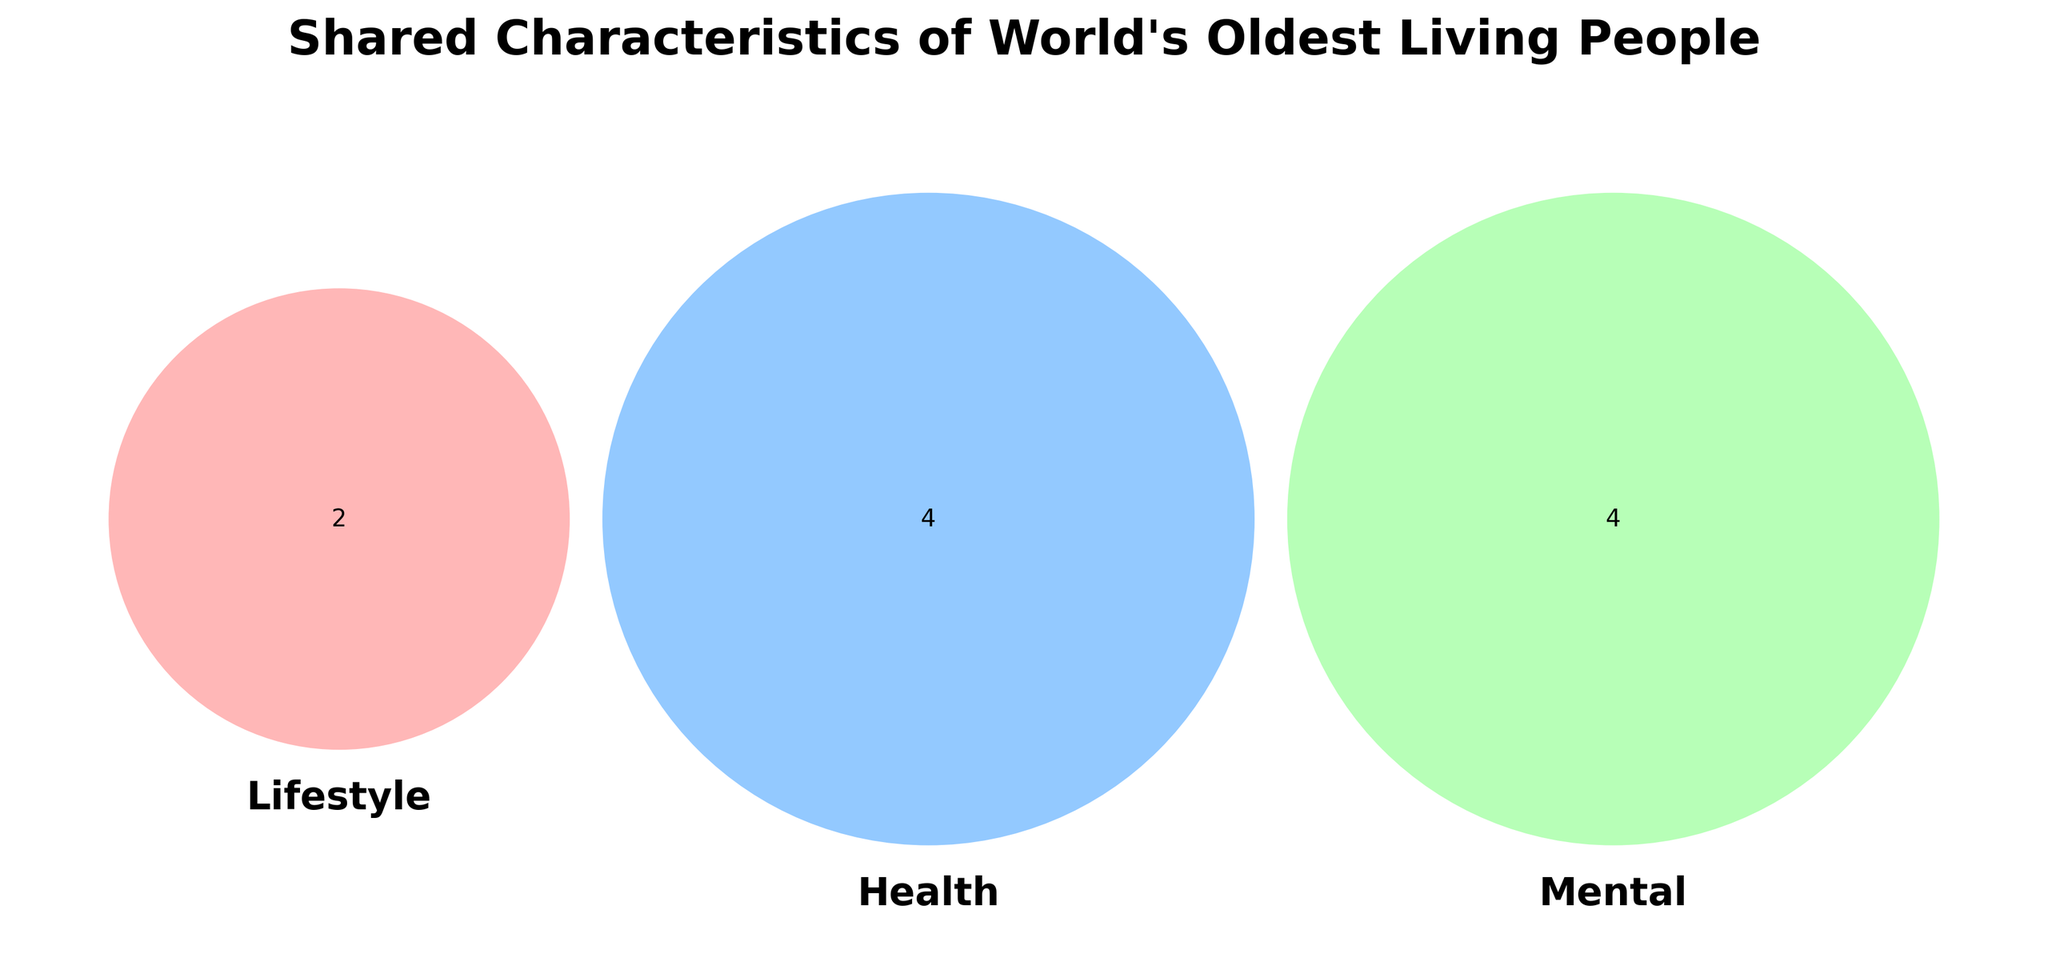What are the three categories represented in the Venn diagram? The Venn diagram shows three circles labeled 'Lifestyle,' 'Health,' and 'Mental.' These are the categories represented.
Answer: Lifestyle, Health, Mental Which category shares characteristics with both 'Lifestyle' and 'Mental'? The overlapping section between 'Lifestyle' and 'Mental' represents shared characteristics. Observing the Venn diagram, the shared characteristics here involve the overlaps of 'Lifestyle' and 'Mental' circles.
Answer: None How many characteristics are unique to the 'Health' category? Each circle in the Venn diagram represents a set of characteristics. The portion of the 'Health' circle that does not overlap with the other circles represents unique characteristics. Counting these sections, we identify unique characteristics.
Answer: 2 Which characteristic is shared among all three categories? The center section where all three circles overlap represents characteristics shared by 'Lifestyle,' 'Health,' and 'Mental.' Observing this intersection, we recognize the shared characteristic.
Answer: None How many characteristics does 'Lifestyle' share with 'Health' but not with 'Mental'? The section where 'Lifestyle' and 'Health' overlap but do not intersect with 'Mental' is found by looking at the corresponding part of the Venn diagram. Counting the characteristics within this overlap gives the answer.
Answer: 1 What colors are used to represent the 'Health' category? The 'Health' circle in the Venn diagram is distinguished by a specific color. By observing the diagram, we can identify that the 'Health' circle is represented with a blue shade.
Answer: Blue Which category shares the most characteristics with 'Mental'? To determine this, identify the circles ('Health' or 'Lifestyle') that have overlaps with 'Mental' and count the overlapping characteristics. Comparing the counts, we find which category shares the most.
Answer: Lifestyle What is the title of the Venn diagram? The title of the Venn diagram is located at the top of the figure and provides context to the visual information.
Answer: Shared Characteristics of World's Oldest Living People How many characteristics are exclusive to 'Mental'? The 'Mental' category's exclusive characteristics are in the part of its circle that does not overlap with 'Lifestyle' or 'Health.' Counting these will give us the answer.
Answer: 2 